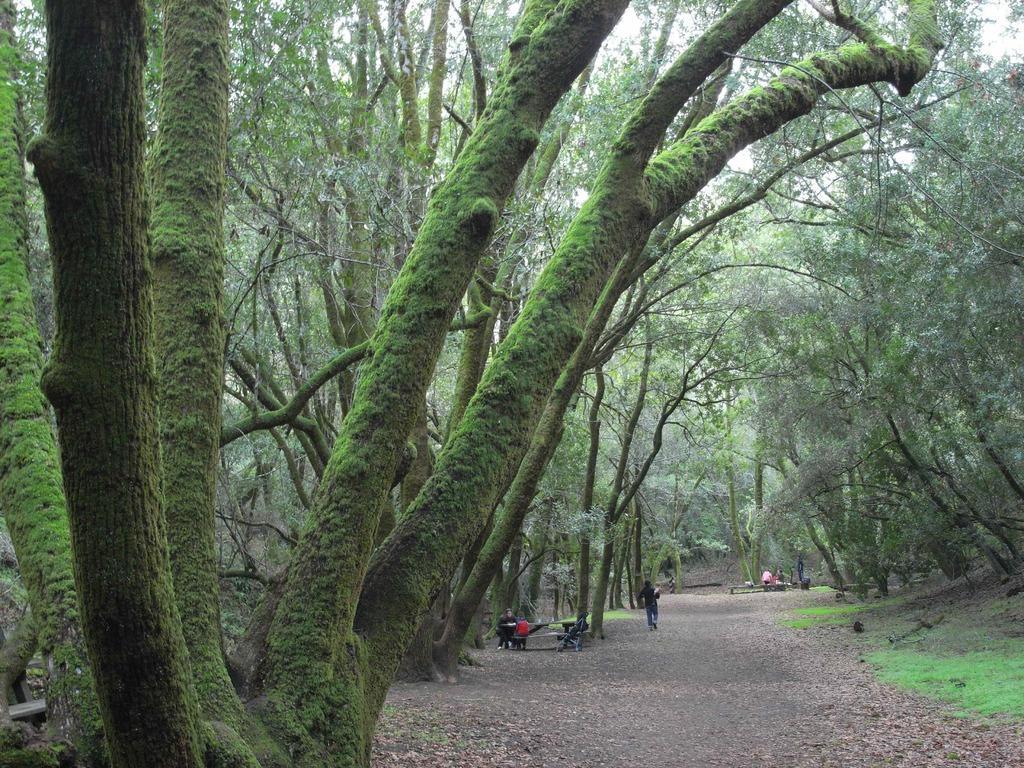In one or two sentences, can you explain what this image depicts? In this picture there are trees on either side of the picture. In the center, there is a lane. At the bottom, there are people sitting on the bench and a man is running on the lane. 